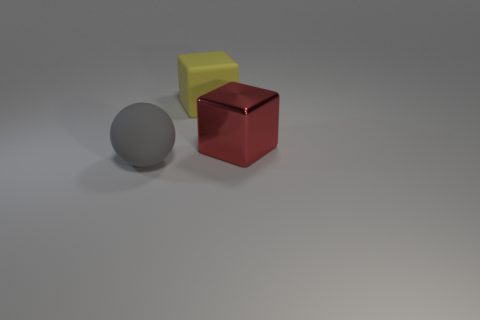Subtract all yellow cubes. Subtract all green balls. How many cubes are left? 1 Add 3 yellow rubber objects. How many objects exist? 6 Subtract all spheres. How many objects are left? 2 Subtract all big rubber cubes. Subtract all gray things. How many objects are left? 1 Add 2 red things. How many red things are left? 3 Add 1 blocks. How many blocks exist? 3 Subtract 0 blue cylinders. How many objects are left? 3 